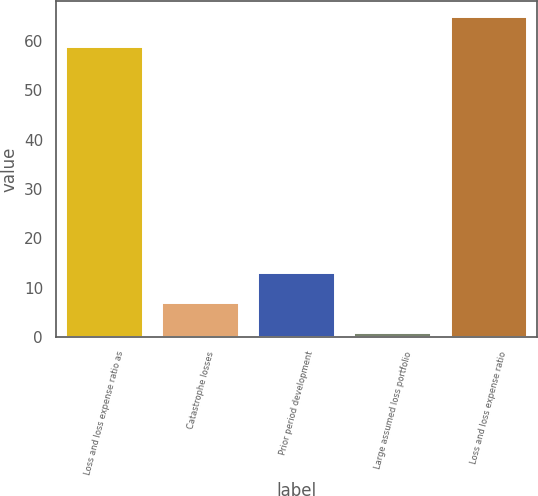<chart> <loc_0><loc_0><loc_500><loc_500><bar_chart><fcel>Loss and loss expense ratio as<fcel>Catastrophe losses<fcel>Prior period development<fcel>Large assumed loss portfolio<fcel>Loss and loss expense ratio<nl><fcel>58.8<fcel>6.89<fcel>12.98<fcel>0.8<fcel>64.89<nl></chart> 